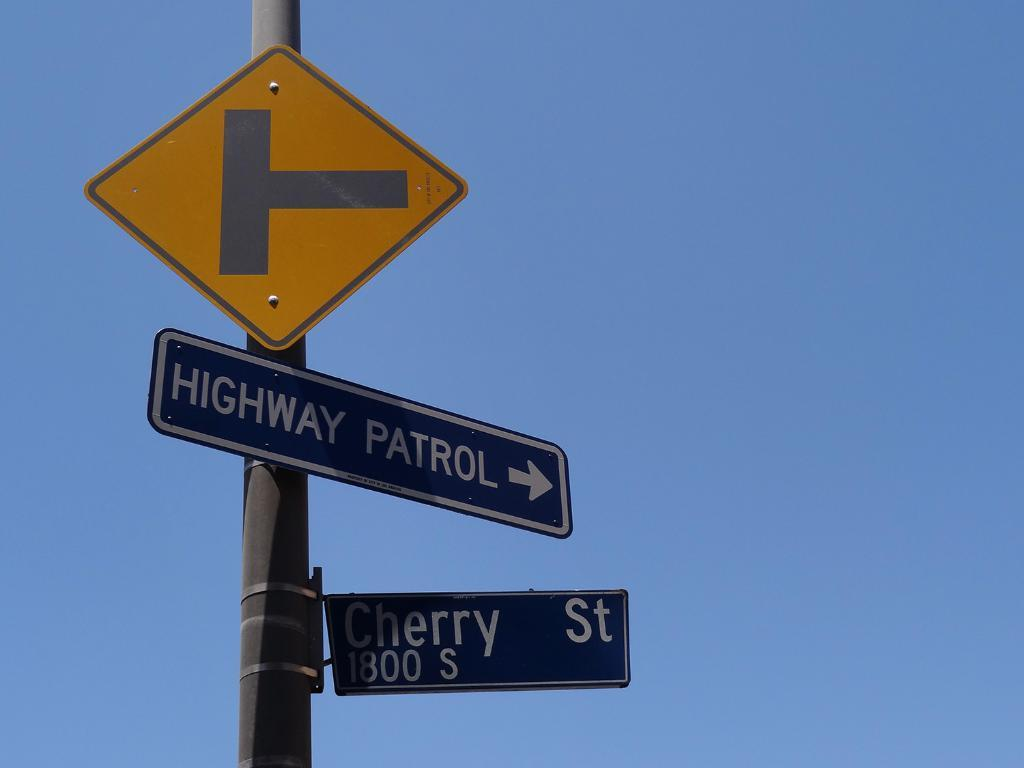<image>
Present a compact description of the photo's key features. A highway patrol direction sign located on Cherry Street. 